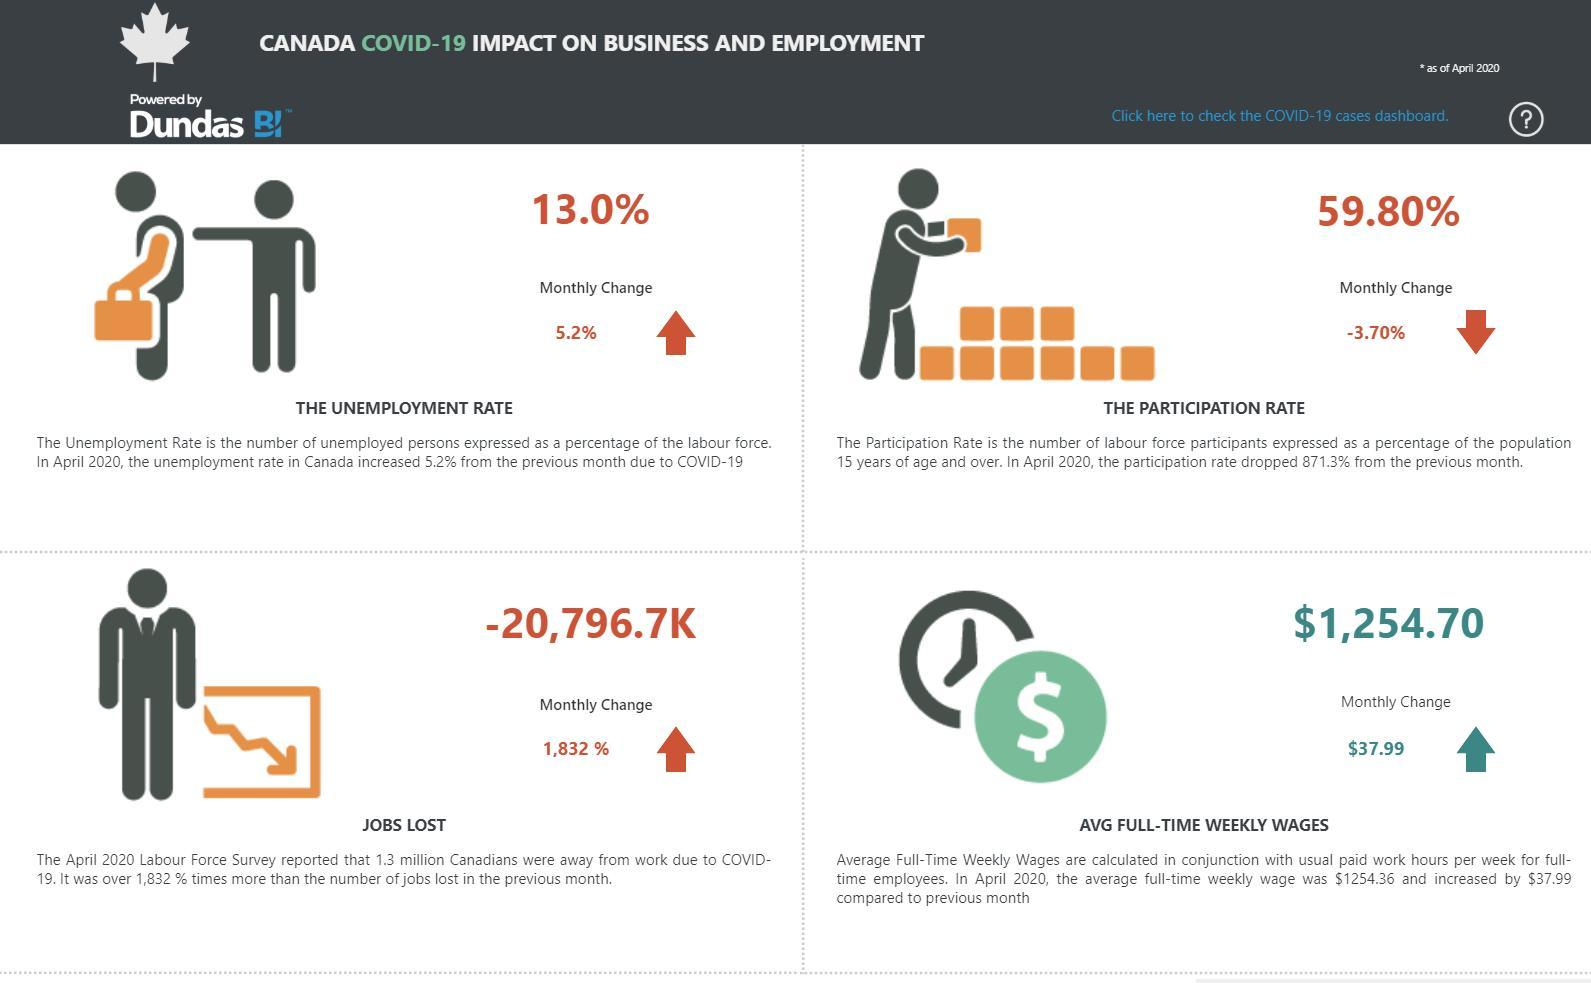What is the total percentage of unemployment and the participation rate, taken together?
Answer the question with a short phrase. 72.8 